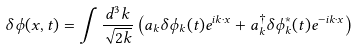<formula> <loc_0><loc_0><loc_500><loc_500>\delta \phi ( x , t ) = \int \frac { d ^ { 3 } k } { \sqrt { 2 k } } \left ( a _ { k } \delta \phi _ { k } ( t ) e ^ { i { k } \cdot { x } } + a _ { k } ^ { \dagger } \delta \phi _ { k } ^ { * } ( t ) e ^ { - i { k } \cdot { x } } \right )</formula> 